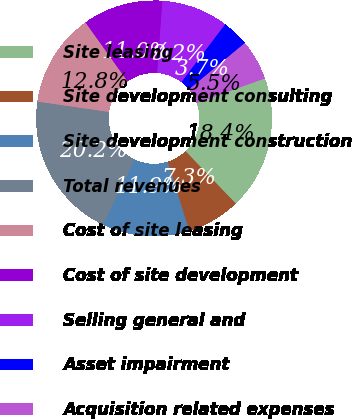<chart> <loc_0><loc_0><loc_500><loc_500><pie_chart><fcel>Site leasing<fcel>Site development consulting<fcel>Site development construction<fcel>Total revenues<fcel>Cost of site leasing<fcel>Cost of site development<fcel>Selling general and<fcel>Asset impairment<fcel>Acquisition related expenses<nl><fcel>18.35%<fcel>7.34%<fcel>11.93%<fcel>20.18%<fcel>12.84%<fcel>11.01%<fcel>9.17%<fcel>3.67%<fcel>5.5%<nl></chart> 